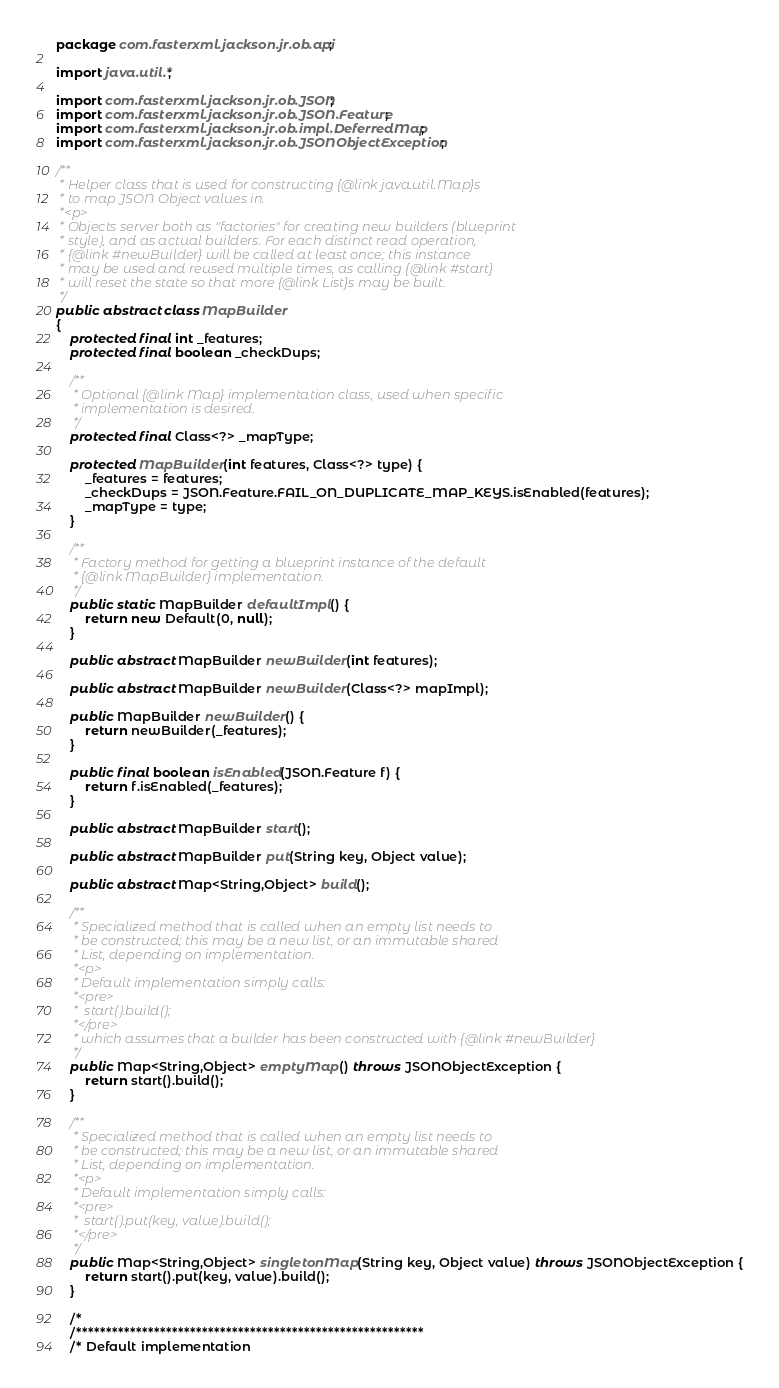Convert code to text. <code><loc_0><loc_0><loc_500><loc_500><_Java_>package com.fasterxml.jackson.jr.ob.api;

import java.util.*;

import com.fasterxml.jackson.jr.ob.JSON;
import com.fasterxml.jackson.jr.ob.JSON.Feature;
import com.fasterxml.jackson.jr.ob.impl.DeferredMap;
import com.fasterxml.jackson.jr.ob.JSONObjectException;

/**
 * Helper class that is used for constructing {@link java.util.Map}s
 * to map JSON Object values in.
 *<p>
 * Objects server both as "factories" for creating new builders (blueprint
 * style), and as actual builders. For each distinct read operation,
 * {@link #newBuilder} will be called at least once; this instance
 * may be used and reused multiple times, as calling {@link #start}
 * will reset the state so that more {@link List}s may be built.
 */
public abstract class MapBuilder
{
    protected final int _features;
    protected final boolean _checkDups;
    
    /**
     * Optional {@link Map} implementation class, used when specific
     * implementation is desired.
     */
    protected final Class<?> _mapType;
    
    protected MapBuilder(int features, Class<?> type) {
        _features = features;
        _checkDups = JSON.Feature.FAIL_ON_DUPLICATE_MAP_KEYS.isEnabled(features);
        _mapType = type;
    }

    /**
     * Factory method for getting a blueprint instance of the default
     * {@link MapBuilder} implementation.
     */
    public static MapBuilder defaultImpl() {
        return new Default(0, null);
    }

    public abstract MapBuilder newBuilder(int features);

    public abstract MapBuilder newBuilder(Class<?> mapImpl);
    
    public MapBuilder newBuilder() {
        return newBuilder(_features);
    }

    public final boolean isEnabled(JSON.Feature f) {
        return f.isEnabled(_features);
    }

    public abstract MapBuilder start();

    public abstract MapBuilder put(String key, Object value);

    public abstract Map<String,Object> build();
    
    /**
     * Specialized method that is called when an empty list needs to
     * be constructed; this may be a new list, or an immutable shared
     * List, depending on implementation.
     *<p>
     * Default implementation simply calls:
     *<pre>
     *  start().build();
     *</pre>
     * which assumes that a builder has been constructed with {@link #newBuilder}
     */
    public Map<String,Object> emptyMap() throws JSONObjectException {
        return start().build();
    }

    /**
     * Specialized method that is called when an empty list needs to
     * be constructed; this may be a new list, or an immutable shared
     * List, depending on implementation.
     *<p>
     * Default implementation simply calls:
     *<pre>
     *  start().put(key, value).build();
     *</pre>
     */
    public Map<String,Object> singletonMap(String key, Object value) throws JSONObjectException {
        return start().put(key, value).build();
    }

    /*
    /**********************************************************
    /* Default implementation</code> 